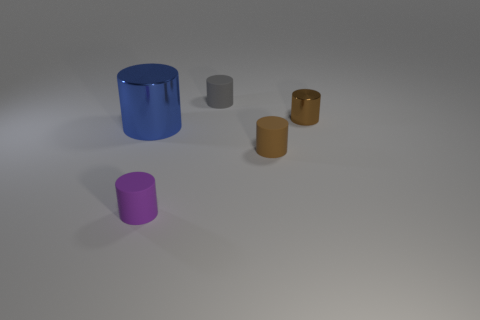What is the shape of the matte thing that is the same color as the small metal cylinder?
Your answer should be compact. Cylinder. Is there a cylinder of the same color as the small metal thing?
Offer a terse response. Yes. There is a rubber cylinder that is the same color as the tiny metallic cylinder; what size is it?
Your response must be concise. Small. Does the small metallic cylinder have the same color as the matte cylinder that is to the right of the tiny gray rubber object?
Offer a terse response. Yes. Is the number of rubber cylinders in front of the blue thing greater than the number of big objects?
Your response must be concise. Yes. What number of small things are to the left of the tiny gray matte object behind the brown cylinder that is behind the large blue cylinder?
Offer a terse response. 1. Do the brown thing in front of the blue cylinder and the brown cylinder to the right of the tiny brown matte cylinder have the same size?
Make the answer very short. Yes. There is a tiny cylinder that is on the left side of the small matte object behind the big blue object; what is its material?
Your response must be concise. Rubber. How many objects are tiny brown things that are behind the big shiny cylinder or cylinders?
Offer a very short reply. 5. Are there the same number of tiny metal cylinders behind the gray rubber object and purple cylinders that are behind the small brown shiny cylinder?
Your answer should be very brief. Yes. 